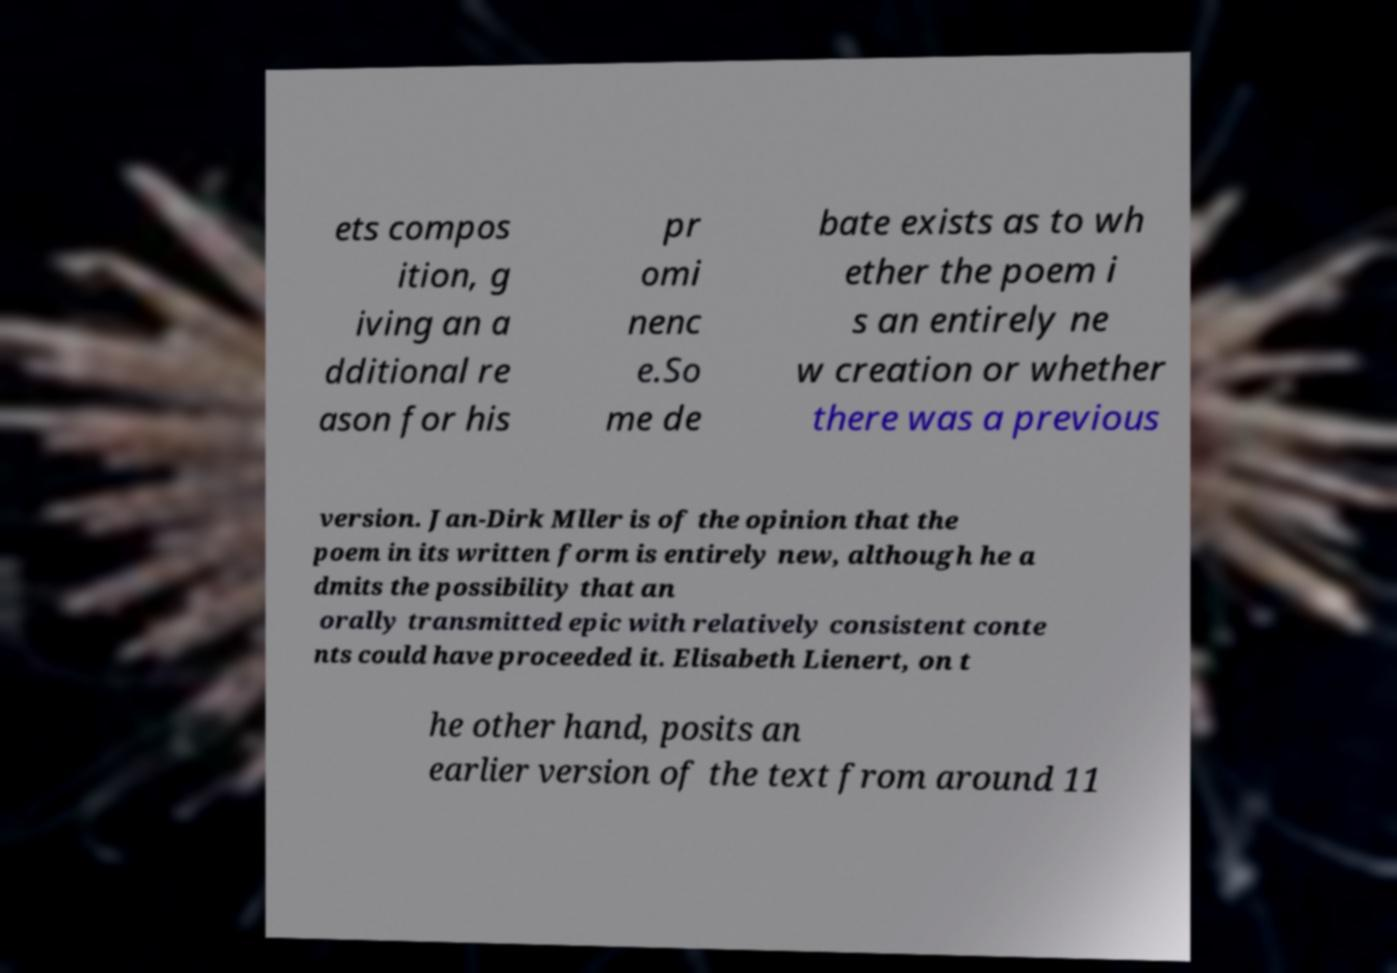For documentation purposes, I need the text within this image transcribed. Could you provide that? ets compos ition, g iving an a dditional re ason for his pr omi nenc e.So me de bate exists as to wh ether the poem i s an entirely ne w creation or whether there was a previous version. Jan-Dirk Mller is of the opinion that the poem in its written form is entirely new, although he a dmits the possibility that an orally transmitted epic with relatively consistent conte nts could have proceeded it. Elisabeth Lienert, on t he other hand, posits an earlier version of the text from around 11 